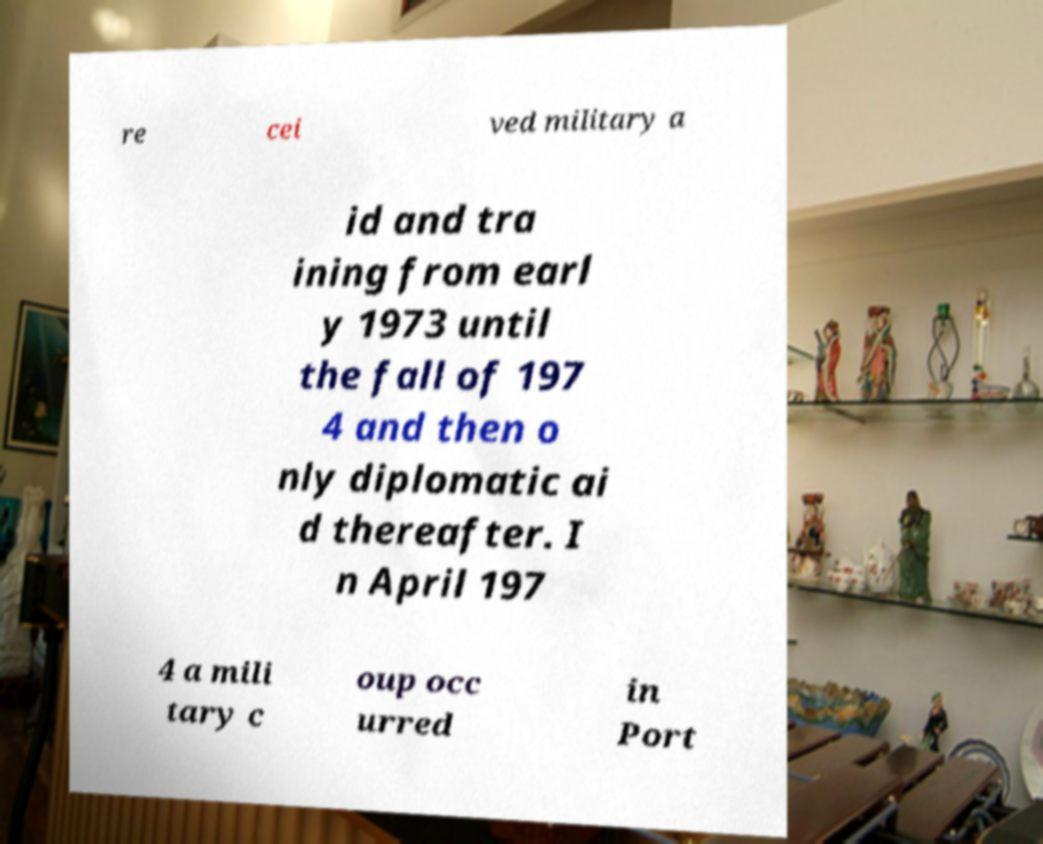Please read and relay the text visible in this image. What does it say? re cei ved military a id and tra ining from earl y 1973 until the fall of 197 4 and then o nly diplomatic ai d thereafter. I n April 197 4 a mili tary c oup occ urred in Port 